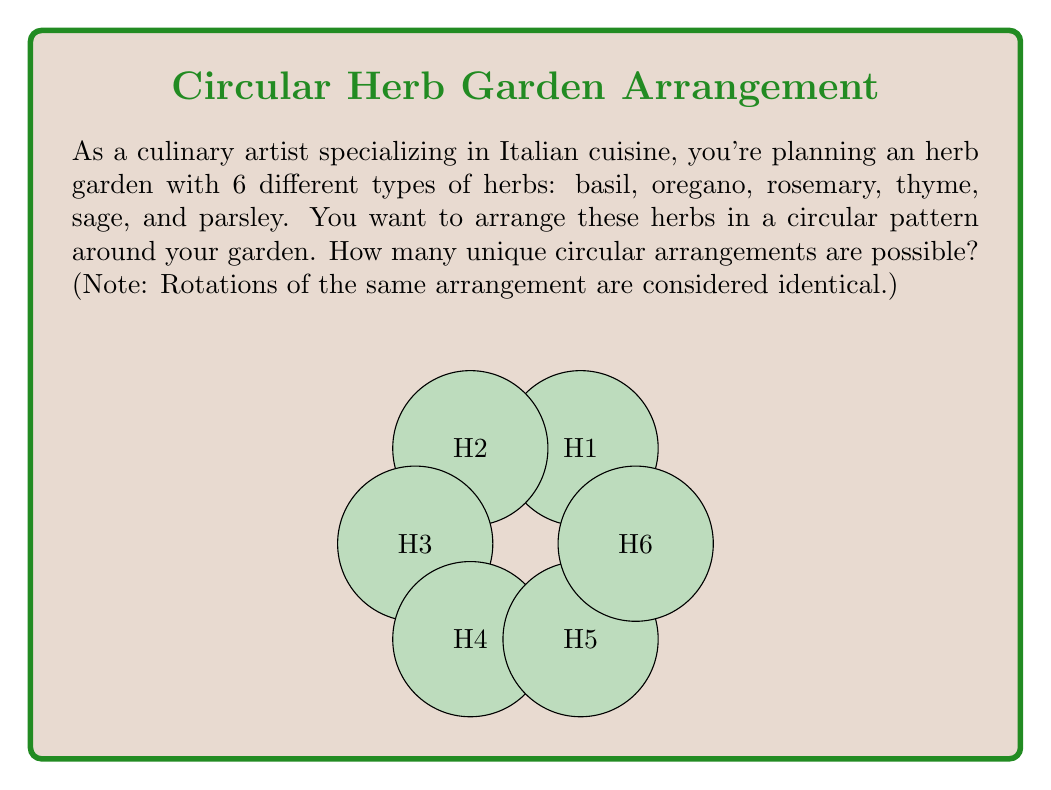Provide a solution to this math problem. To solve this problem, we need to use the concept of circular permutations from Group theory. Here's a step-by-step explanation:

1) First, recall that for n distinct objects, the number of linear permutations is n!.

2) However, in a circular arrangement, rotations of the same arrangement are considered identical. For example, (basil, oregano, rosemary, thyme, sage, parsley) is the same as (oregano, rosemary, thyme, sage, parsley, basil) when arranged in a circle.

3) In fact, each unique circular arrangement corresponds to n different linear arrangements (one for each rotation). This means we need to divide the total number of linear permutations by n.

4) The formula for the number of unique circular permutations of n distinct objects is:

   $$(n-1)!$$

5) In this case, we have 6 different herbs, so n = 6.

6) Plugging this into our formula:

   $$(6-1)! = 5! = 5 \times 4 \times 3 \times 2 \times 1 = 120$$

Therefore, there are 120 unique circular arrangements possible for the 6 herbs in your garden.
Answer: 120 